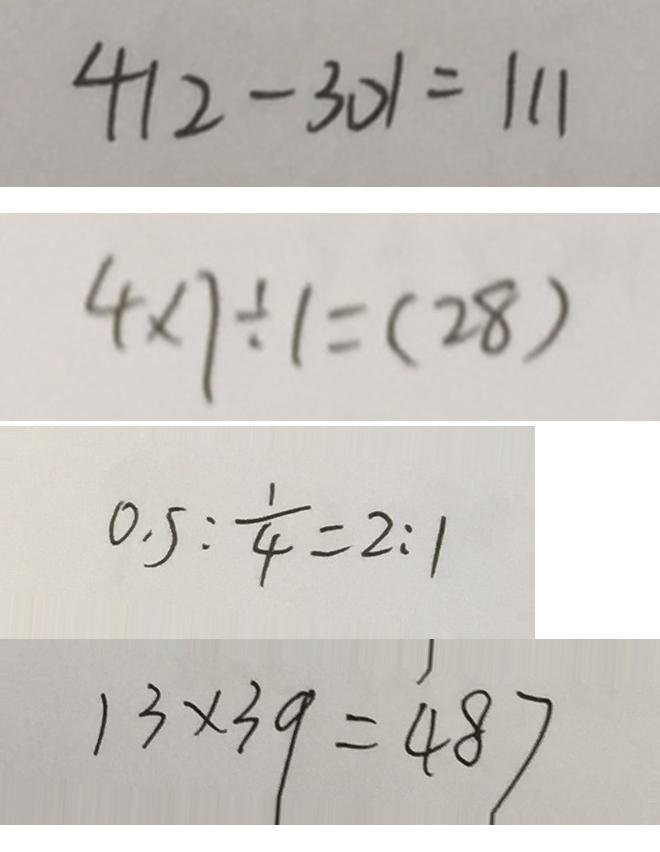Convert formula to latex. <formula><loc_0><loc_0><loc_500><loc_500>4 1 2 - 3 0 1 = 1 1 1 
 4 \times 7 \div 1 = ( 2 8 ) 
 0 . 5 : \frac { 1 } { 4 } = 2 : 1 
 1 3 \times 3 9 = 4 8 7</formula> 